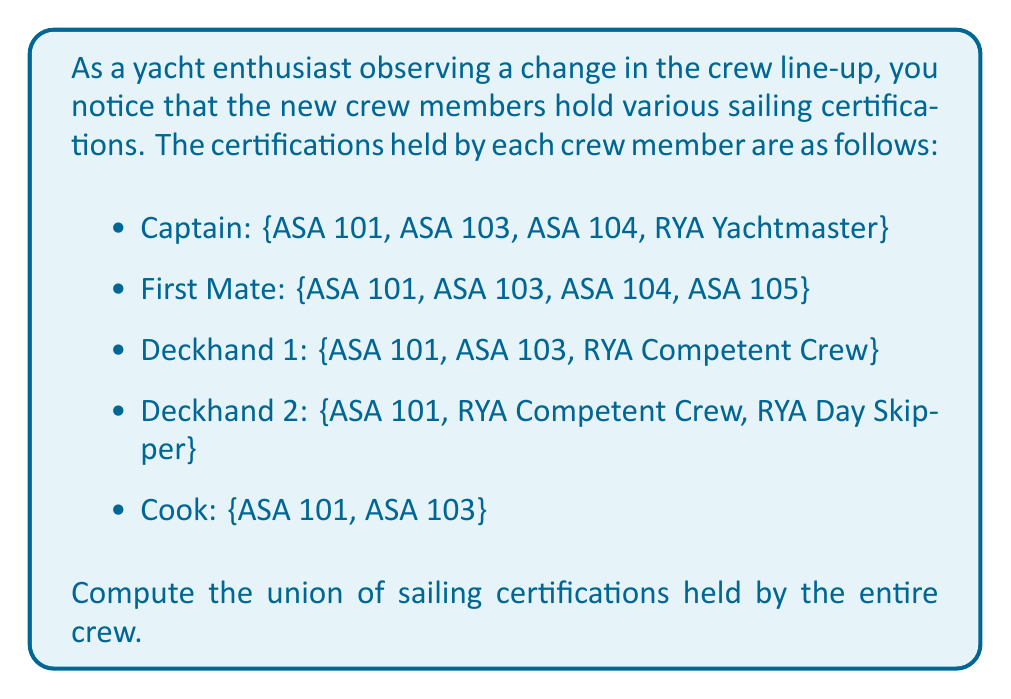Help me with this question. To solve this problem, we need to find the union of all the sets of certifications held by each crew member. Let's approach this step-by-step:

1. First, let's define sets for each crew member's certifications:

   Captain (C) = {ASA 101, ASA 103, ASA 104, RYA Yachtmaster}
   First Mate (FM) = {ASA 101, ASA 103, ASA 104, ASA 105}
   Deckhand 1 (D1) = {ASA 101, ASA 103, RYA Competent Crew}
   Deckhand 2 (D2) = {ASA 101, RYA Competent Crew, RYA Day Skipper}
   Cook (CO) = {ASA 101, ASA 103}

2. The union of these sets will give us all unique certifications held by the entire crew. We can represent this mathematically as:

   $$ U = C \cup FM \cup D1 \cup D2 \cup CO $$

3. To compute this union, we list all unique elements from all sets:

   - ASA 101 (appears in all sets)
   - ASA 103 (appears in C, FM, D1, and CO)
   - ASA 104 (appears in C and FM)
   - ASA 105 (appears in FM)
   - RYA Yachtmaster (appears in C)
   - RYA Competent Crew (appears in D1 and D2)
   - RYA Day Skipper (appears in D2)

4. The resulting union is the set of all these unique certifications.
Answer: The union of sailing certifications held by the entire crew is:

$$ U = \{ASA 101, ASA 103, ASA 104, ASA 105, RYA Yachtmaster, RYA Competent Crew, RYA Day Skipper\} $$ 